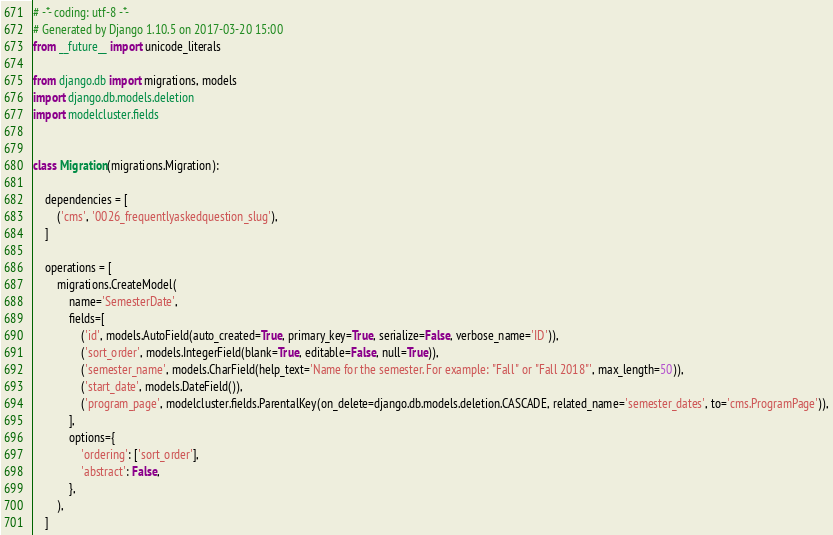<code> <loc_0><loc_0><loc_500><loc_500><_Python_># -*- coding: utf-8 -*-
# Generated by Django 1.10.5 on 2017-03-20 15:00
from __future__ import unicode_literals

from django.db import migrations, models
import django.db.models.deletion
import modelcluster.fields


class Migration(migrations.Migration):

    dependencies = [
        ('cms', '0026_frequentlyaskedquestion_slug'),
    ]

    operations = [
        migrations.CreateModel(
            name='SemesterDate',
            fields=[
                ('id', models.AutoField(auto_created=True, primary_key=True, serialize=False, verbose_name='ID')),
                ('sort_order', models.IntegerField(blank=True, editable=False, null=True)),
                ('semester_name', models.CharField(help_text='Name for the semester. For example: "Fall" or "Fall 2018"', max_length=50)),
                ('start_date', models.DateField()),
                ('program_page', modelcluster.fields.ParentalKey(on_delete=django.db.models.deletion.CASCADE, related_name='semester_dates', to='cms.ProgramPage')),
            ],
            options={
                'ordering': ['sort_order'],
                'abstract': False,
            },
        ),
    ]
</code> 